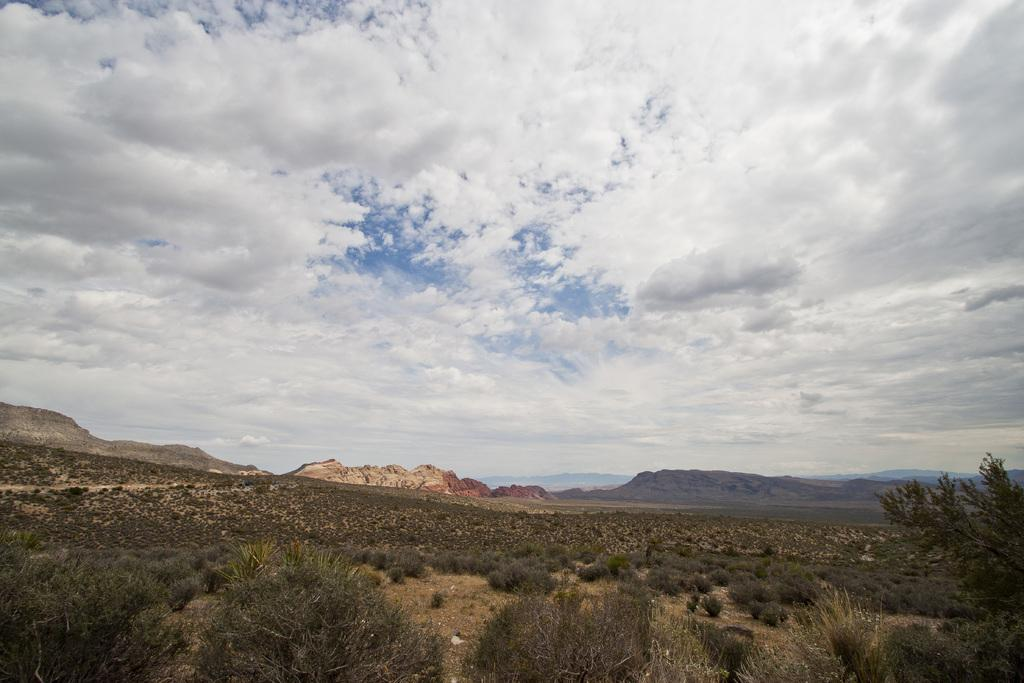What type of vegetation can be seen in the image? There are plants and a tree in the image. What type of landscape feature is present in the image? There are hills in the image. What is the condition of the sky in the image? The sky is cloudy in the image. Can you see a basket being used for driving in the image? There is no basket or driving activity present in the image. Is there a veil covering the tree in the image? There is no veil present in the image, and the tree is not covered. 